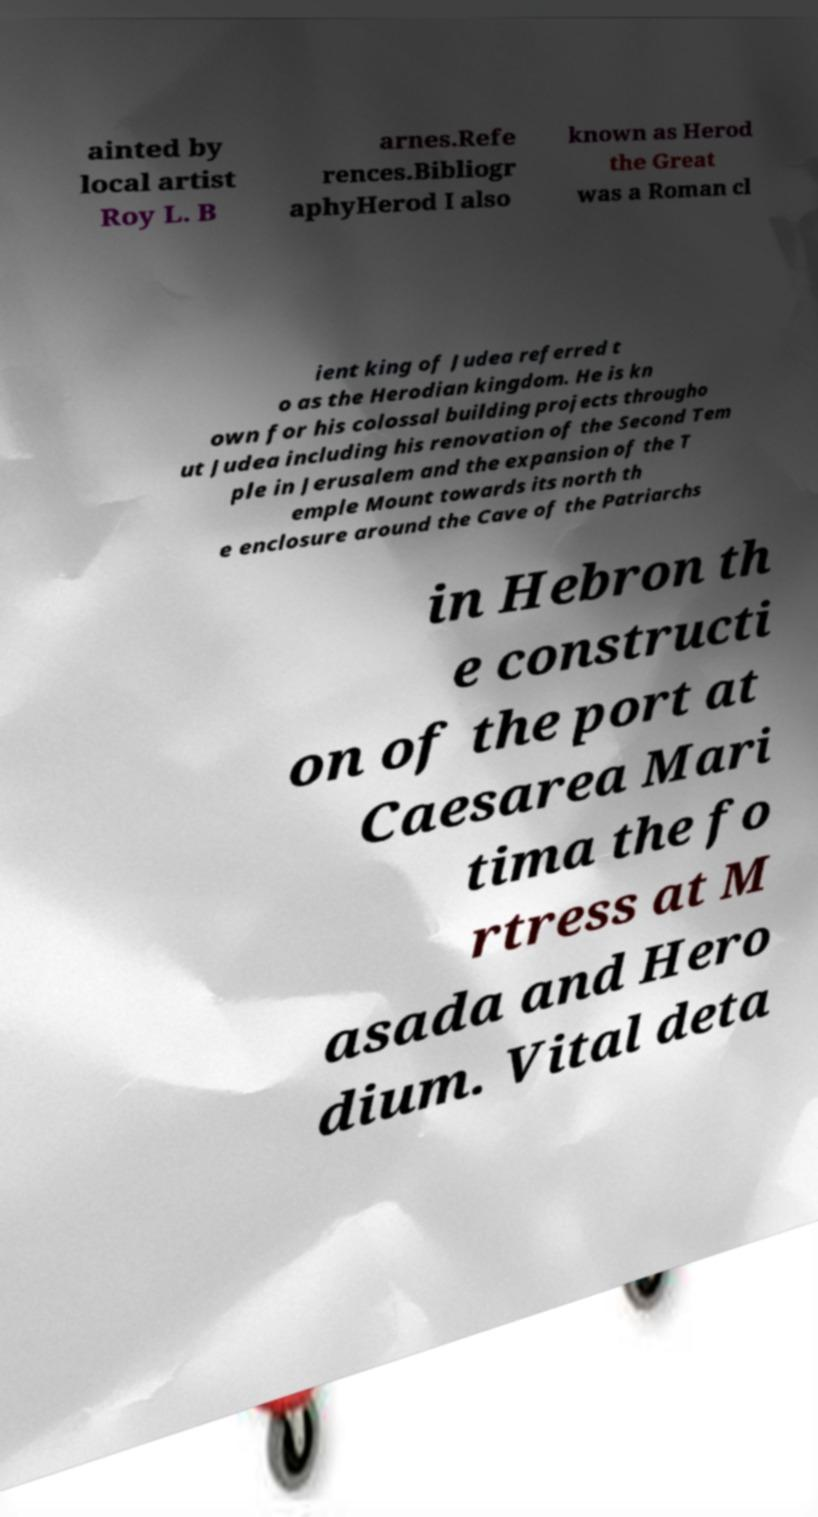For documentation purposes, I need the text within this image transcribed. Could you provide that? ainted by local artist Roy L. B arnes.Refe rences.Bibliogr aphyHerod I also known as Herod the Great was a Roman cl ient king of Judea referred t o as the Herodian kingdom. He is kn own for his colossal building projects througho ut Judea including his renovation of the Second Tem ple in Jerusalem and the expansion of the T emple Mount towards its north th e enclosure around the Cave of the Patriarchs in Hebron th e constructi on of the port at Caesarea Mari tima the fo rtress at M asada and Hero dium. Vital deta 